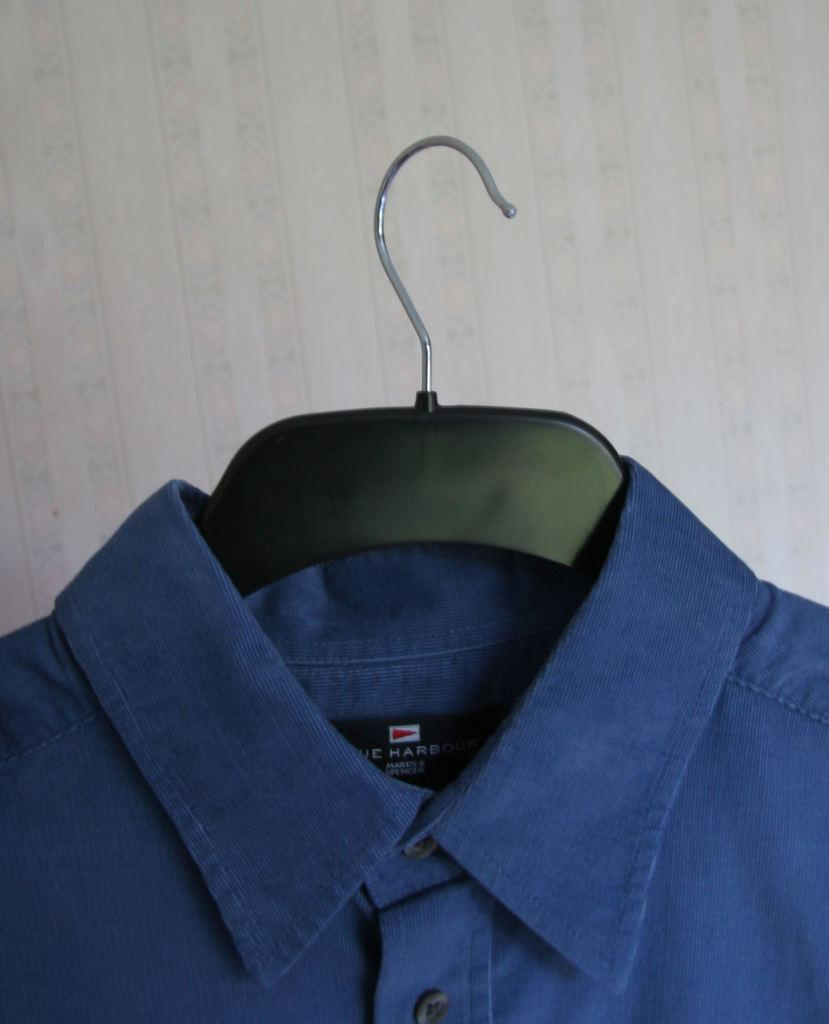What type of clothing item is in the image? There is a shirt in the image. How is the shirt positioned in the image? The shirt is on a hanger. What arithmetic problem is being solved on the shirt in the image? There is no arithmetic problem visible on the shirt in the image. 